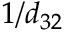Convert formula to latex. <formula><loc_0><loc_0><loc_500><loc_500>1 / d _ { 3 2 }</formula> 